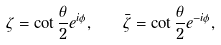Convert formula to latex. <formula><loc_0><loc_0><loc_500><loc_500>\zeta = \cot { \frac { \theta } { 2 } } e ^ { i \phi } , \quad \bar { \zeta } = \cot { \frac { \theta } { 2 } } e ^ { - i \phi } ,</formula> 